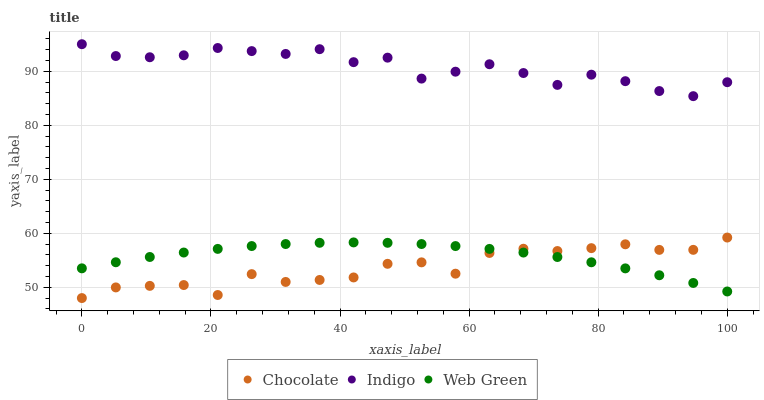Does Chocolate have the minimum area under the curve?
Answer yes or no. Yes. Does Indigo have the maximum area under the curve?
Answer yes or no. Yes. Does Web Green have the minimum area under the curve?
Answer yes or no. No. Does Web Green have the maximum area under the curve?
Answer yes or no. No. Is Web Green the smoothest?
Answer yes or no. Yes. Is Chocolate the roughest?
Answer yes or no. Yes. Is Chocolate the smoothest?
Answer yes or no. No. Is Web Green the roughest?
Answer yes or no. No. Does Chocolate have the lowest value?
Answer yes or no. Yes. Does Web Green have the lowest value?
Answer yes or no. No. Does Indigo have the highest value?
Answer yes or no. Yes. Does Chocolate have the highest value?
Answer yes or no. No. Is Chocolate less than Indigo?
Answer yes or no. Yes. Is Indigo greater than Chocolate?
Answer yes or no. Yes. Does Chocolate intersect Web Green?
Answer yes or no. Yes. Is Chocolate less than Web Green?
Answer yes or no. No. Is Chocolate greater than Web Green?
Answer yes or no. No. Does Chocolate intersect Indigo?
Answer yes or no. No. 